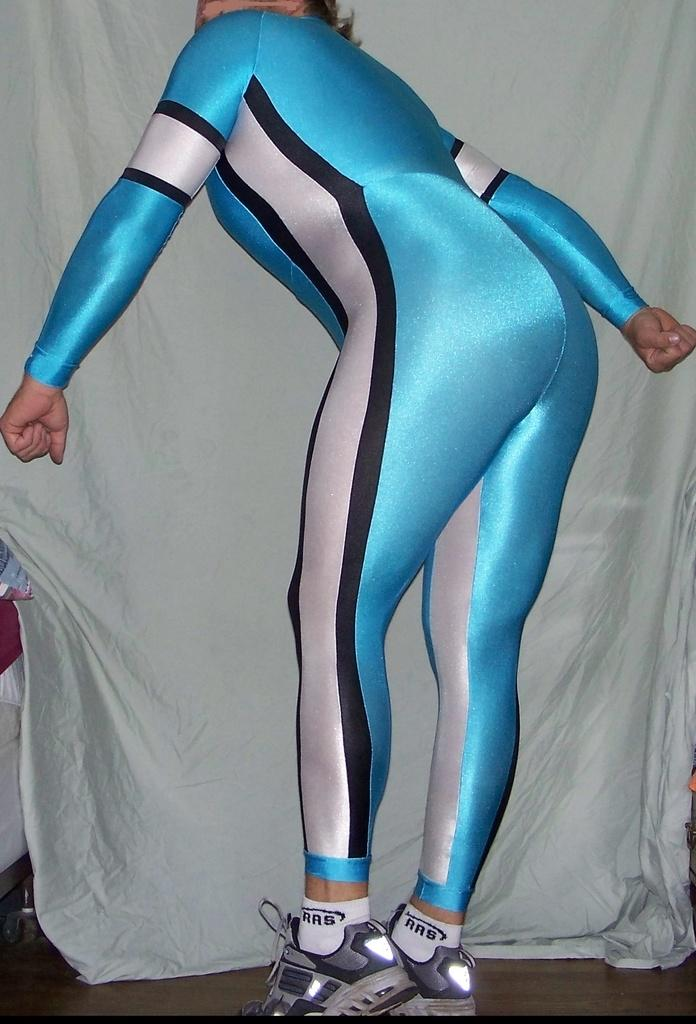<image>
Relay a brief, clear account of the picture shown. A woman wearing a blue jumpsuit is wearing RRS socks 